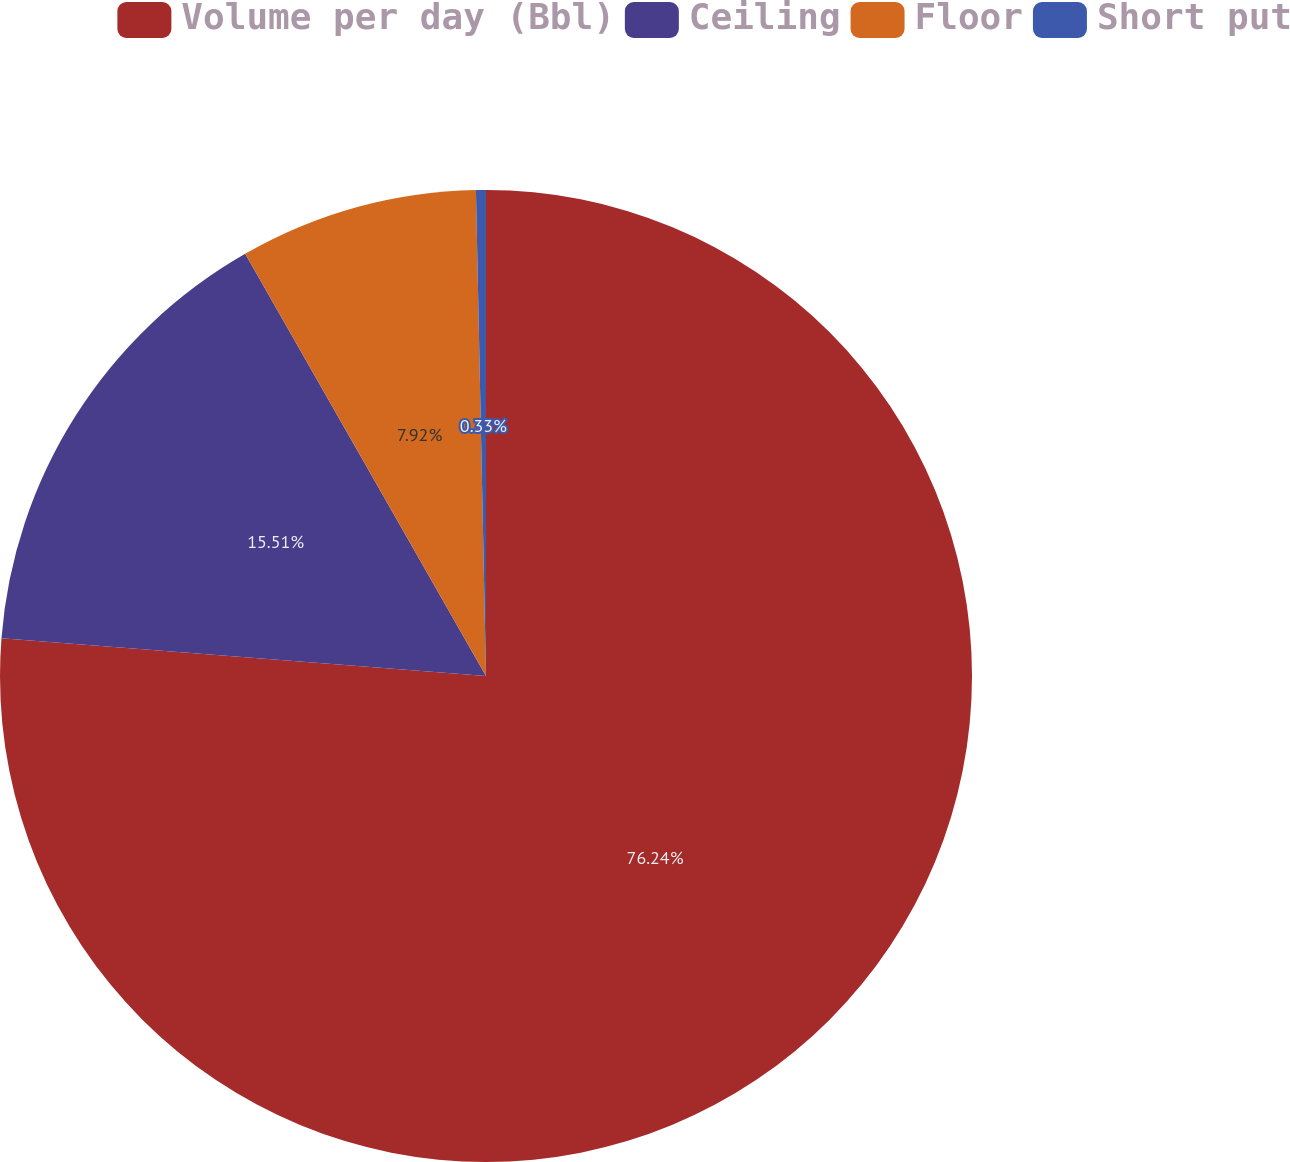<chart> <loc_0><loc_0><loc_500><loc_500><pie_chart><fcel>Volume per day (Bbl)<fcel>Ceiling<fcel>Floor<fcel>Short put<nl><fcel>76.24%<fcel>15.51%<fcel>7.92%<fcel>0.33%<nl></chart> 